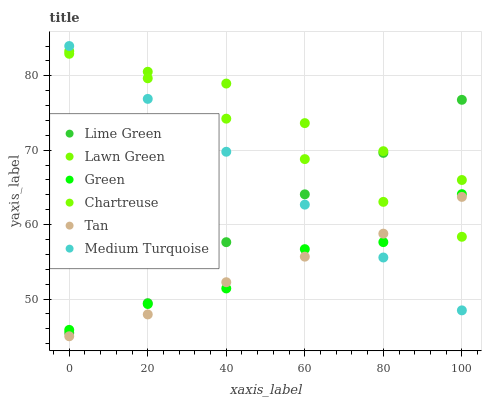Does Tan have the minimum area under the curve?
Answer yes or no. Yes. Does Lawn Green have the maximum area under the curve?
Answer yes or no. Yes. Does Chartreuse have the minimum area under the curve?
Answer yes or no. No. Does Chartreuse have the maximum area under the curve?
Answer yes or no. No. Is Medium Turquoise the smoothest?
Answer yes or no. Yes. Is Green the roughest?
Answer yes or no. Yes. Is Chartreuse the smoothest?
Answer yes or no. No. Is Chartreuse the roughest?
Answer yes or no. No. Does Tan have the lowest value?
Answer yes or no. Yes. Does Chartreuse have the lowest value?
Answer yes or no. No. Does Medium Turquoise have the highest value?
Answer yes or no. Yes. Does Chartreuse have the highest value?
Answer yes or no. No. Is Tan less than Lime Green?
Answer yes or no. Yes. Is Lawn Green greater than Green?
Answer yes or no. Yes. Does Medium Turquoise intersect Lime Green?
Answer yes or no. Yes. Is Medium Turquoise less than Lime Green?
Answer yes or no. No. Is Medium Turquoise greater than Lime Green?
Answer yes or no. No. Does Tan intersect Lime Green?
Answer yes or no. No. 